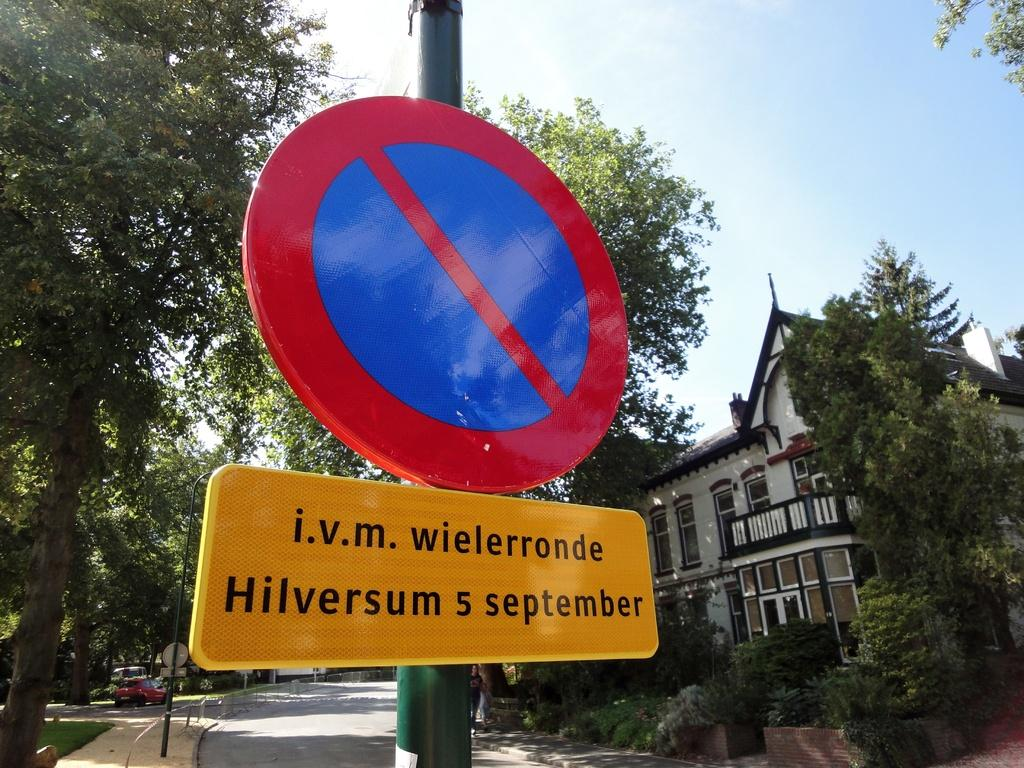<image>
Describe the image concisely. A sign on a pole that says i.v.m. wielerronder written in black. 